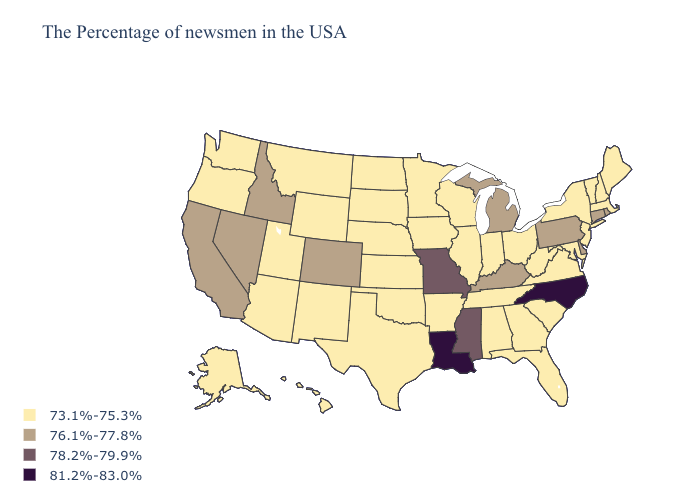What is the highest value in states that border Oregon?
Give a very brief answer. 76.1%-77.8%. Name the states that have a value in the range 76.1%-77.8%?
Quick response, please. Rhode Island, Connecticut, Delaware, Pennsylvania, Michigan, Kentucky, Colorado, Idaho, Nevada, California. Does Mississippi have the lowest value in the USA?
Write a very short answer. No. Name the states that have a value in the range 73.1%-75.3%?
Give a very brief answer. Maine, Massachusetts, New Hampshire, Vermont, New York, New Jersey, Maryland, Virginia, South Carolina, West Virginia, Ohio, Florida, Georgia, Indiana, Alabama, Tennessee, Wisconsin, Illinois, Arkansas, Minnesota, Iowa, Kansas, Nebraska, Oklahoma, Texas, South Dakota, North Dakota, Wyoming, New Mexico, Utah, Montana, Arizona, Washington, Oregon, Alaska, Hawaii. Is the legend a continuous bar?
Be succinct. No. What is the value of Louisiana?
Be succinct. 81.2%-83.0%. Does West Virginia have the lowest value in the USA?
Be succinct. Yes. Name the states that have a value in the range 78.2%-79.9%?
Give a very brief answer. Mississippi, Missouri. Does North Carolina have the highest value in the USA?
Write a very short answer. Yes. Does Colorado have the lowest value in the USA?
Answer briefly. No. Among the states that border Mississippi , does Louisiana have the lowest value?
Be succinct. No. Does the map have missing data?
Give a very brief answer. No. Which states have the lowest value in the West?
Write a very short answer. Wyoming, New Mexico, Utah, Montana, Arizona, Washington, Oregon, Alaska, Hawaii. Does Missouri have the lowest value in the MidWest?
Short answer required. No. Name the states that have a value in the range 78.2%-79.9%?
Short answer required. Mississippi, Missouri. 